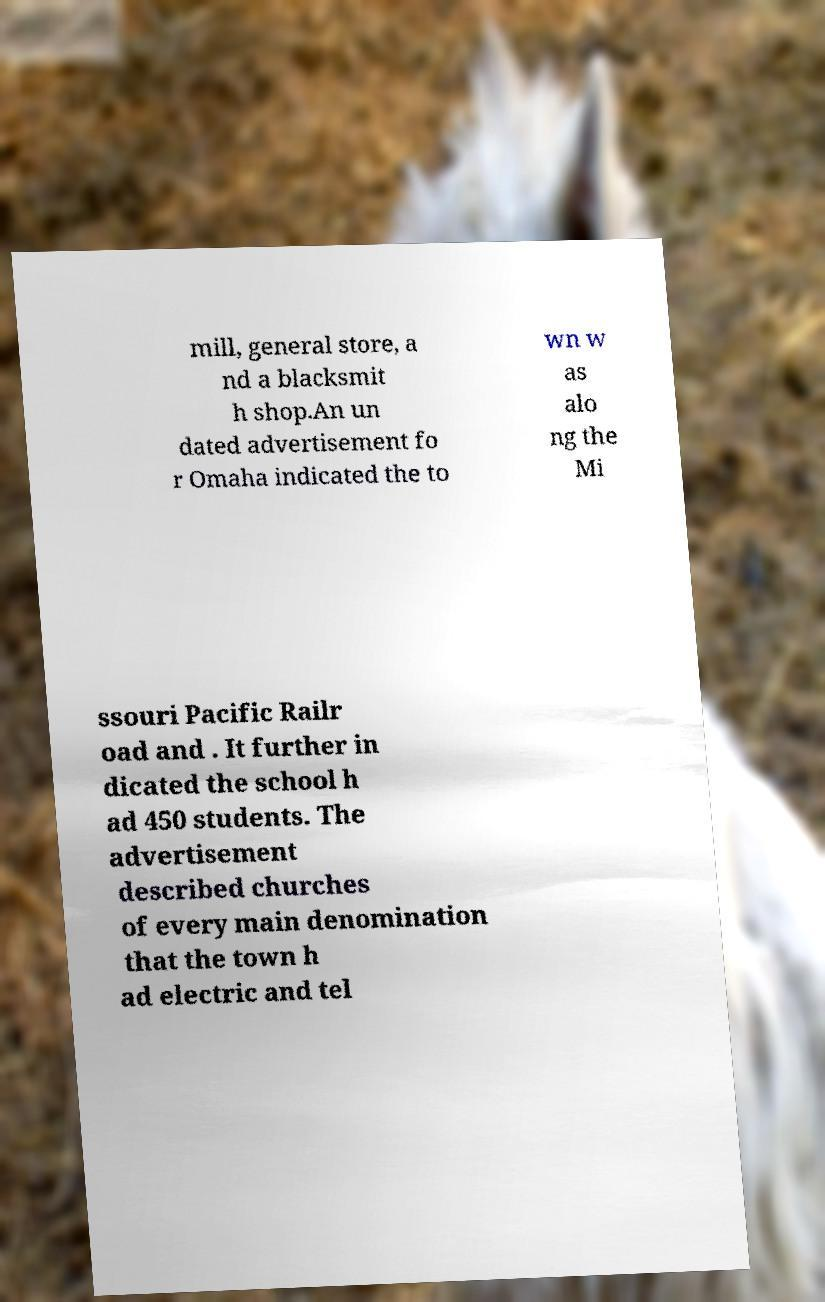Please identify and transcribe the text found in this image. mill, general store, a nd a blacksmit h shop.An un dated advertisement fo r Omaha indicated the to wn w as alo ng the Mi ssouri Pacific Railr oad and . It further in dicated the school h ad 450 students. The advertisement described churches of every main denomination that the town h ad electric and tel 